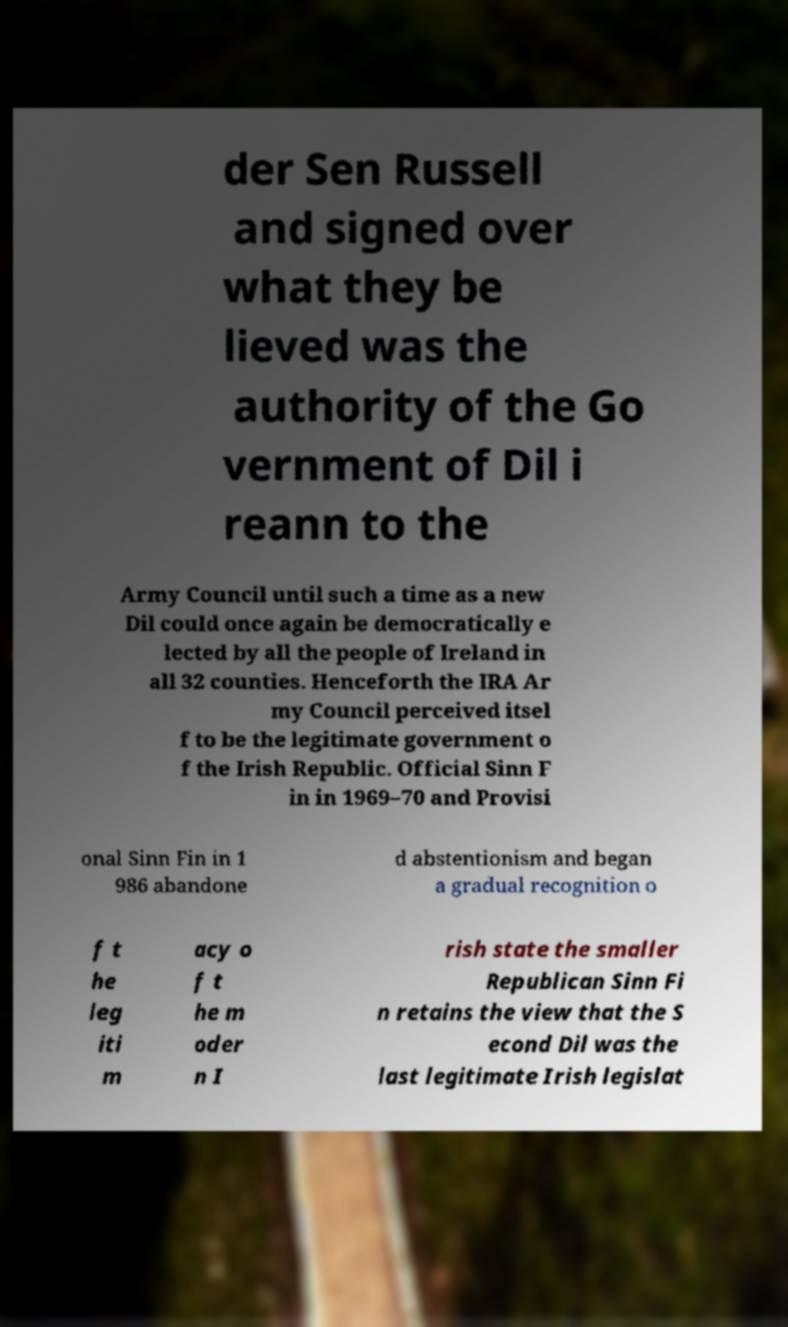Can you accurately transcribe the text from the provided image for me? der Sen Russell and signed over what they be lieved was the authority of the Go vernment of Dil i reann to the Army Council until such a time as a new Dil could once again be democratically e lected by all the people of Ireland in all 32 counties. Henceforth the IRA Ar my Council perceived itsel f to be the legitimate government o f the Irish Republic. Official Sinn F in in 1969–70 and Provisi onal Sinn Fin in 1 986 abandone d abstentionism and began a gradual recognition o f t he leg iti m acy o f t he m oder n I rish state the smaller Republican Sinn Fi n retains the view that the S econd Dil was the last legitimate Irish legislat 